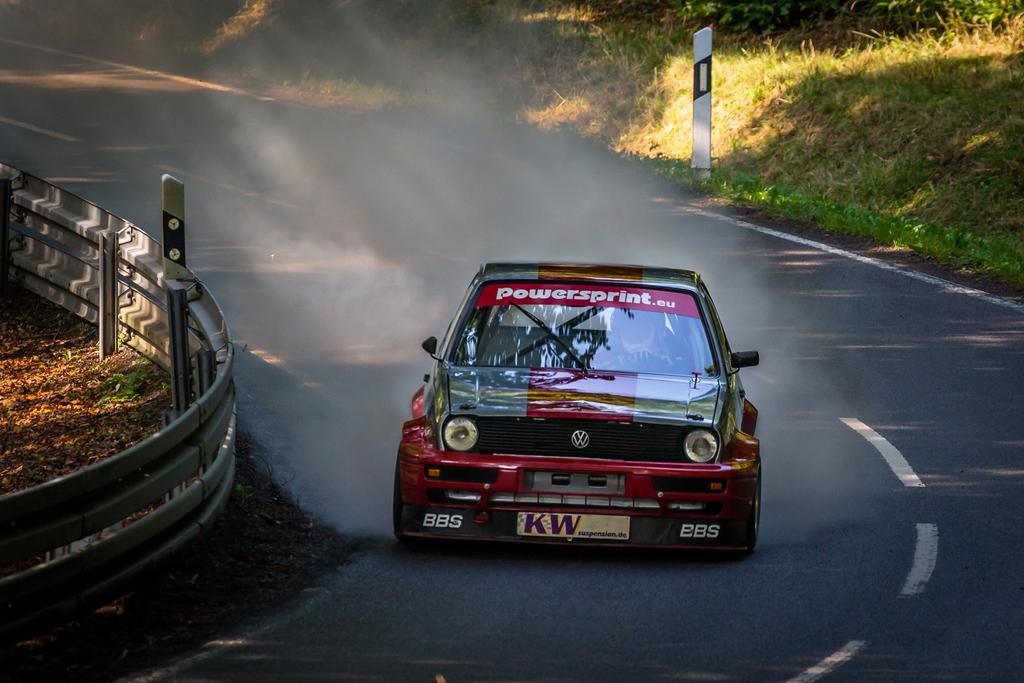What color is the car in the image? The car in the image is red. What is the car doing in the image? The car is moving on the road. What can be seen on the left side of the image? There is railing on the left side of the image. What type of vegetation is on the right side of the image? There is grass on the right side of the image. What type of sound can be heard coming from the potato in the image? There is no potato present in the image, and therefore no sound can be heard from it. 